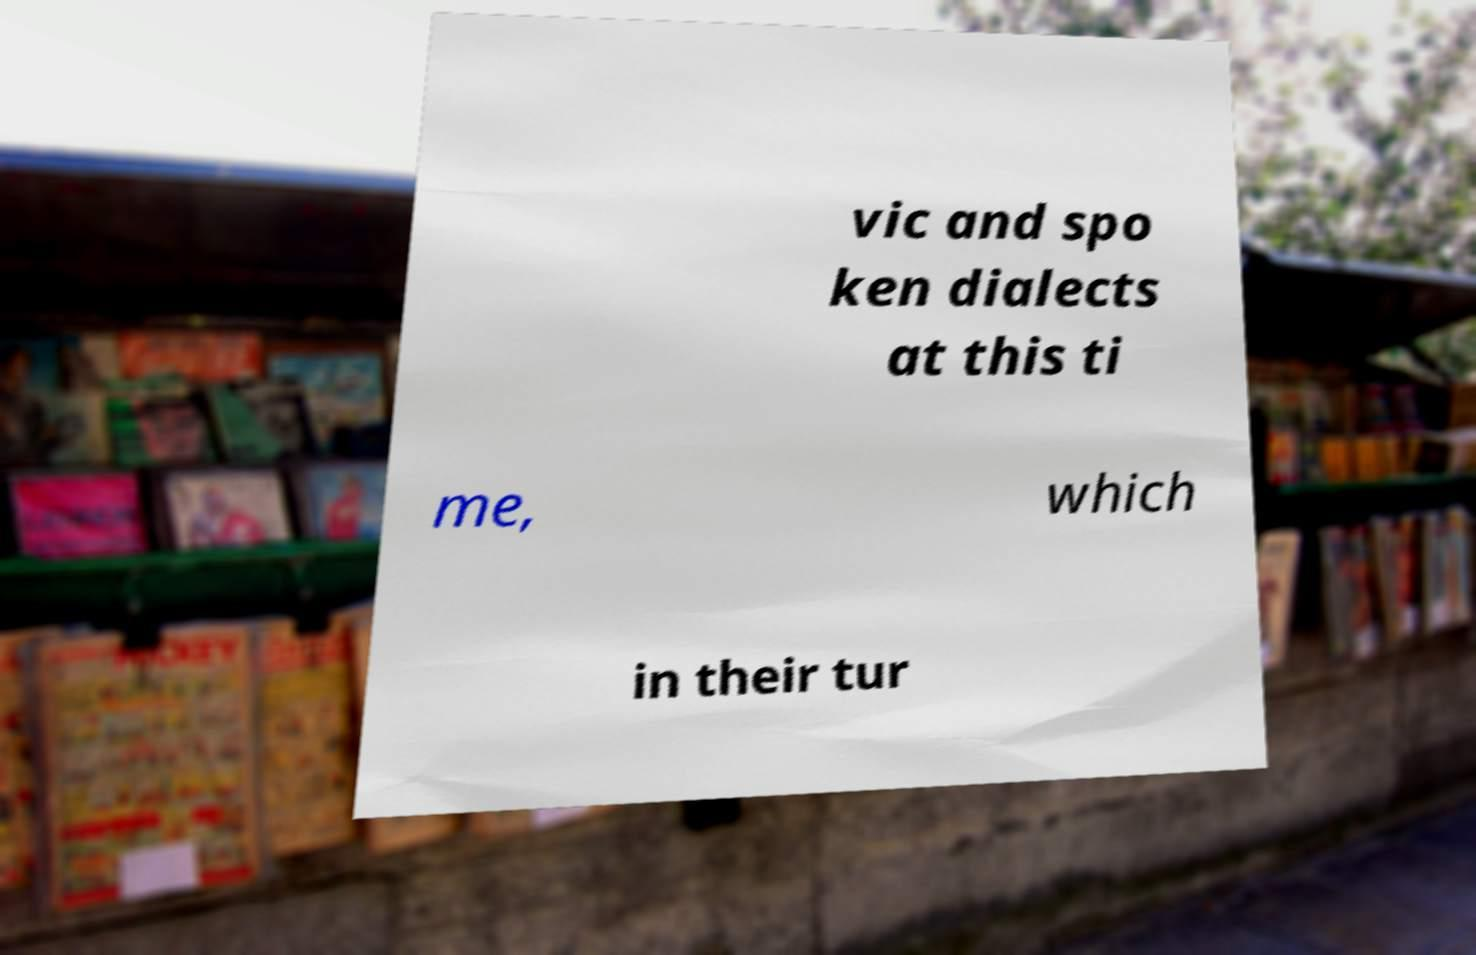What messages or text are displayed in this image? I need them in a readable, typed format. vic and spo ken dialects at this ti me, which in their tur 